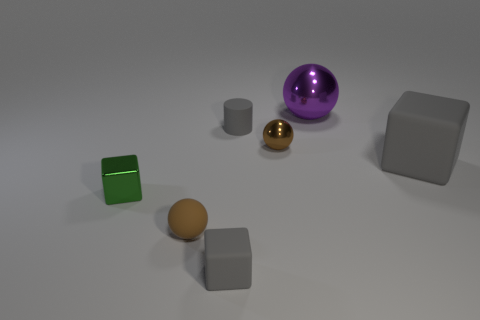There is a brown rubber object; what shape is it?
Make the answer very short. Sphere. What number of other big blocks have the same material as the green block?
Offer a terse response. 0. What is the color of the ball that is made of the same material as the small gray cylinder?
Give a very brief answer. Brown. There is a gray cylinder; is its size the same as the sphere behind the tiny brown metal ball?
Provide a succinct answer. No. The gray block that is on the left side of the metallic thing behind the gray rubber cylinder on the right side of the green object is made of what material?
Your answer should be very brief. Rubber. How many things are rubber cubes or spheres?
Your answer should be compact. 5. There is a tiny ball that is behind the small green thing; is it the same color as the matte cube on the right side of the big purple metallic object?
Your answer should be compact. No. What shape is the green thing that is the same size as the brown metallic object?
Provide a short and direct response. Cube. What number of objects are either gray blocks behind the small metallic cube or brown objects that are on the right side of the tiny cylinder?
Offer a terse response. 2. Is the number of large green shiny balls less than the number of big gray blocks?
Offer a very short reply. Yes. 